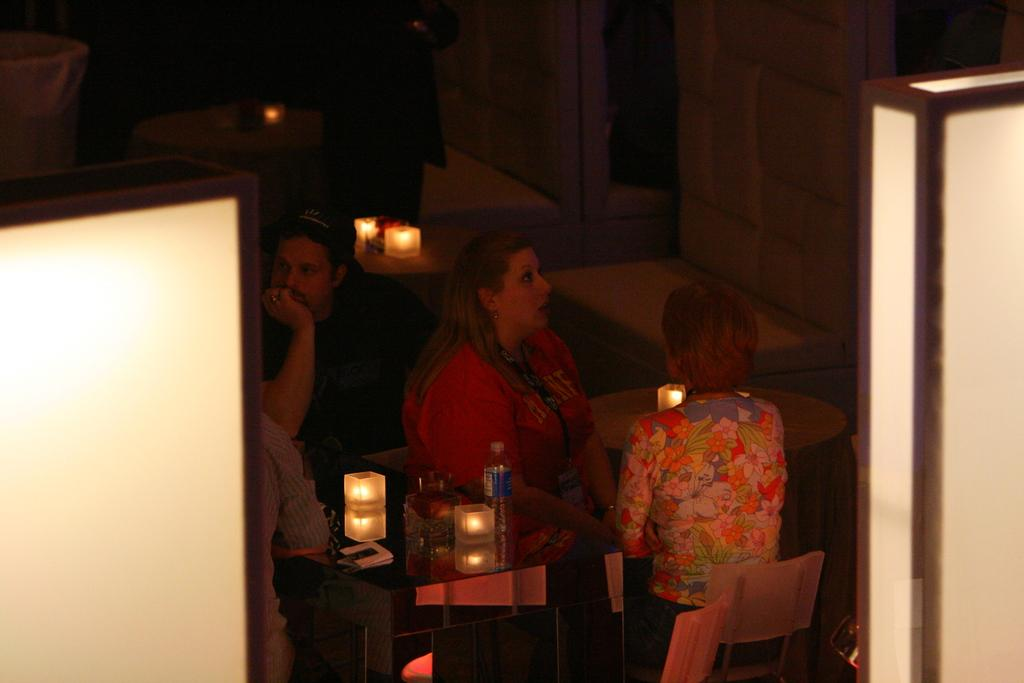What is happening in the room in the image? There are people sitting in a room. What furniture is present in the room? There is a table in the room. What items can be seen on the table? There is a bottle, a light, and a bowl on the table. What can be seen in the background of the image? In the background, there are cupboards and tables. What type of skin is visible on the people in the image? There is no information about the skin of the people in the image, as the focus is on their presence and the objects around them. 